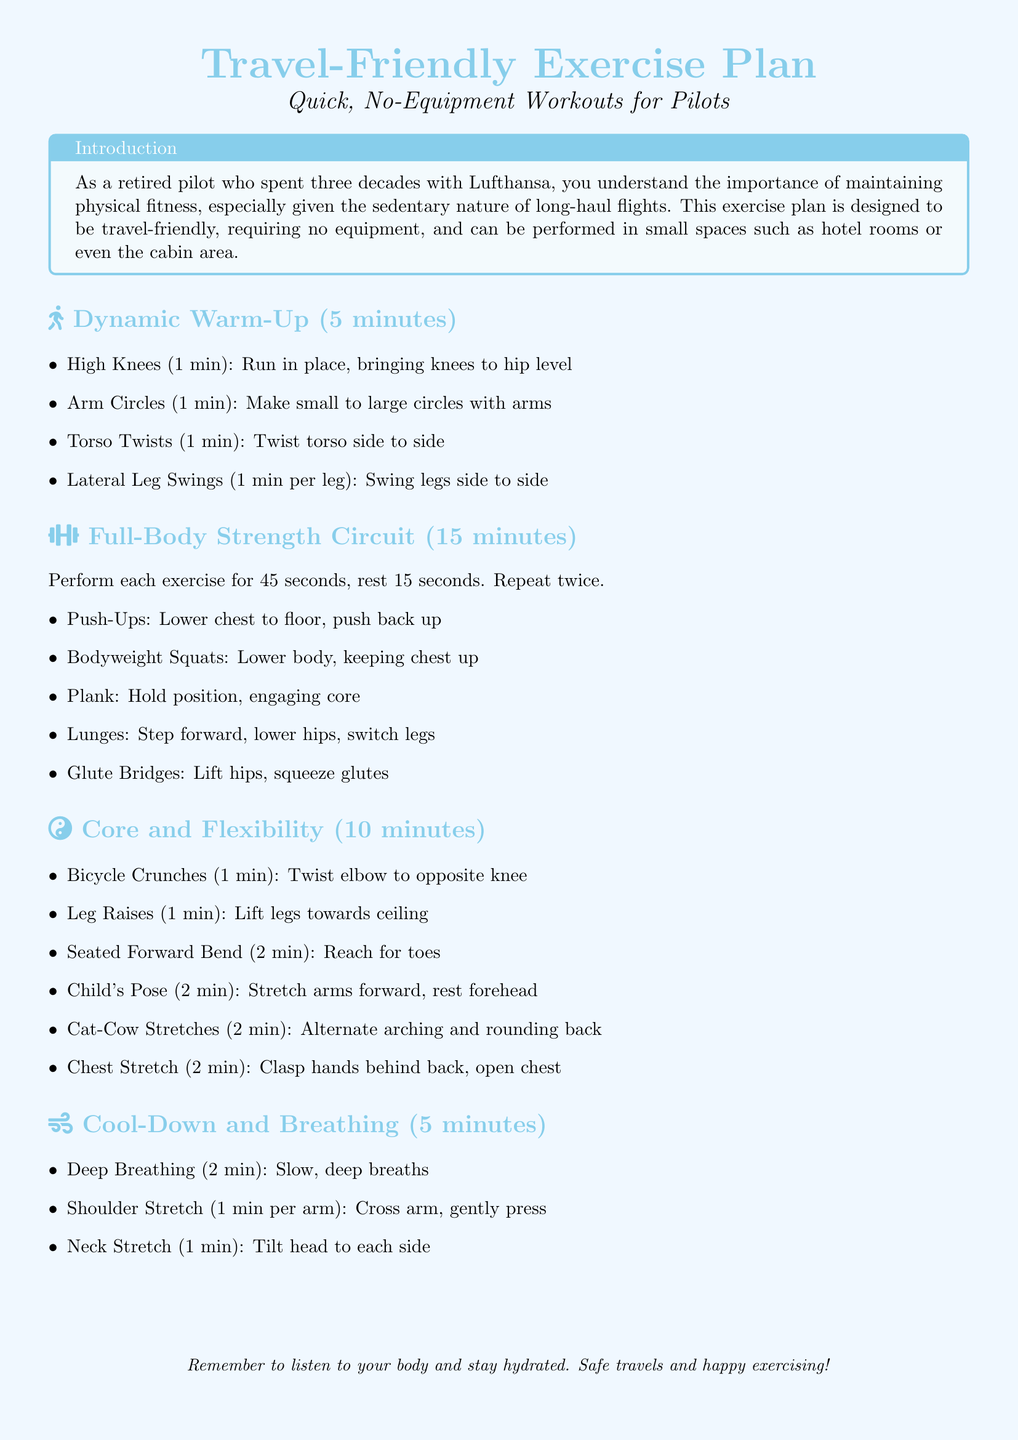What is the title of the document? The title of the document is presented prominently at the beginning.
Answer: Travel-Friendly Exercise Plan How long is the full-body strength circuit? The duration for the full-body strength circuit is specified in the document.
Answer: 15 minutes What exercise comes first in the dynamic warm-up? The document lists exercise order in the dynamic warm-up section.
Answer: High Knees How long should you perform bicycle crunches? The duration for the bicycle crunches is provided in the document.
Answer: 1 minute What is the total duration of the cool-down and breathing section? The document specifies the time allocation for this section.
Answer: 5 minutes How many exercises are included in the strength circuit? The document details the number of exercises in the strength circuit.
Answer: 5 exercises What should you remember to do while exercising? The document includes a reminder at the end.
Answer: Stay hydrated Which stretch is performed for 2 minutes in the core and flexibility section? The document mentions specific durations for each exercise.
Answer: Seated Forward Bend What type of workout does this plan focus on? The document highlights the nature of the workouts provided.
Answer: No-Equipment Workouts 